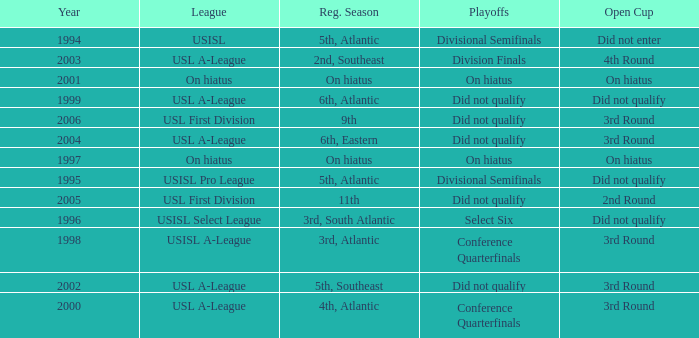I'm looking to parse the entire table for insights. Could you assist me with that? {'header': ['Year', 'League', 'Reg. Season', 'Playoffs', 'Open Cup'], 'rows': [['1994', 'USISL', '5th, Atlantic', 'Divisional Semifinals', 'Did not enter'], ['2003', 'USL A-League', '2nd, Southeast', 'Division Finals', '4th Round'], ['2001', 'On hiatus', 'On hiatus', 'On hiatus', 'On hiatus'], ['1999', 'USL A-League', '6th, Atlantic', 'Did not qualify', 'Did not qualify'], ['2006', 'USL First Division', '9th', 'Did not qualify', '3rd Round'], ['2004', 'USL A-League', '6th, Eastern', 'Did not qualify', '3rd Round'], ['1997', 'On hiatus', 'On hiatus', 'On hiatus', 'On hiatus'], ['1995', 'USISL Pro League', '5th, Atlantic', 'Divisional Semifinals', 'Did not qualify'], ['2005', 'USL First Division', '11th', 'Did not qualify', '2nd Round'], ['1996', 'USISL Select League', '3rd, South Atlantic', 'Select Six', 'Did not qualify'], ['1998', 'USISL A-League', '3rd, Atlantic', 'Conference Quarterfinals', '3rd Round'], ['2002', 'USL A-League', '5th, Southeast', 'Did not qualify', '3rd Round'], ['2000', 'USL A-League', '4th, Atlantic', 'Conference Quarterfinals', '3rd Round']]} What was the earliest year for the USISL Pro League? 1995.0. 